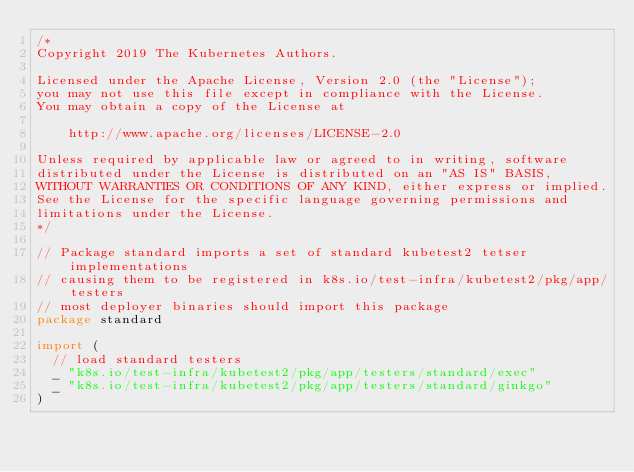<code> <loc_0><loc_0><loc_500><loc_500><_Go_>/*
Copyright 2019 The Kubernetes Authors.

Licensed under the Apache License, Version 2.0 (the "License");
you may not use this file except in compliance with the License.
You may obtain a copy of the License at

    http://www.apache.org/licenses/LICENSE-2.0

Unless required by applicable law or agreed to in writing, software
distributed under the License is distributed on an "AS IS" BASIS,
WITHOUT WARRANTIES OR CONDITIONS OF ANY KIND, either express or implied.
See the License for the specific language governing permissions and
limitations under the License.
*/

// Package standard imports a set of standard kubetest2 tetser implementations
// causing them to be registered in k8s.io/test-infra/kubetest2/pkg/app/testers
// most deployer binaries should import this package
package standard

import (
	// load standard testers
	_ "k8s.io/test-infra/kubetest2/pkg/app/testers/standard/exec"
	_ "k8s.io/test-infra/kubetest2/pkg/app/testers/standard/ginkgo"
)
</code> 